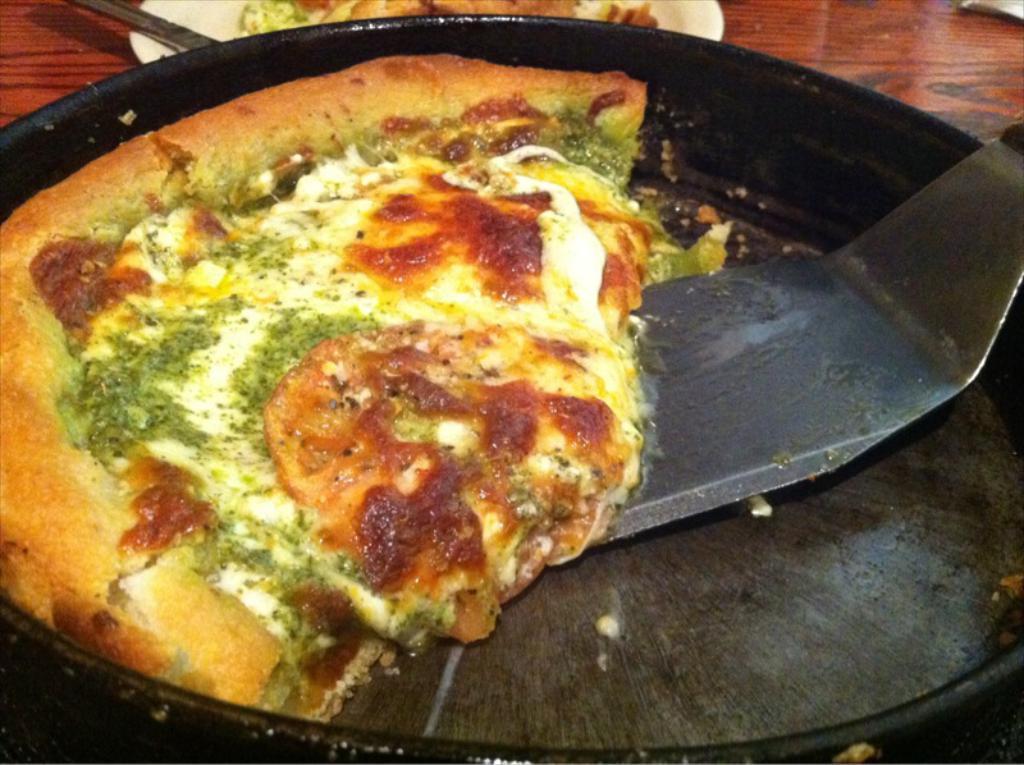How would you summarize this image in a sentence or two? In this image we can see a serving plate which consists of pie and a spatula in it. 